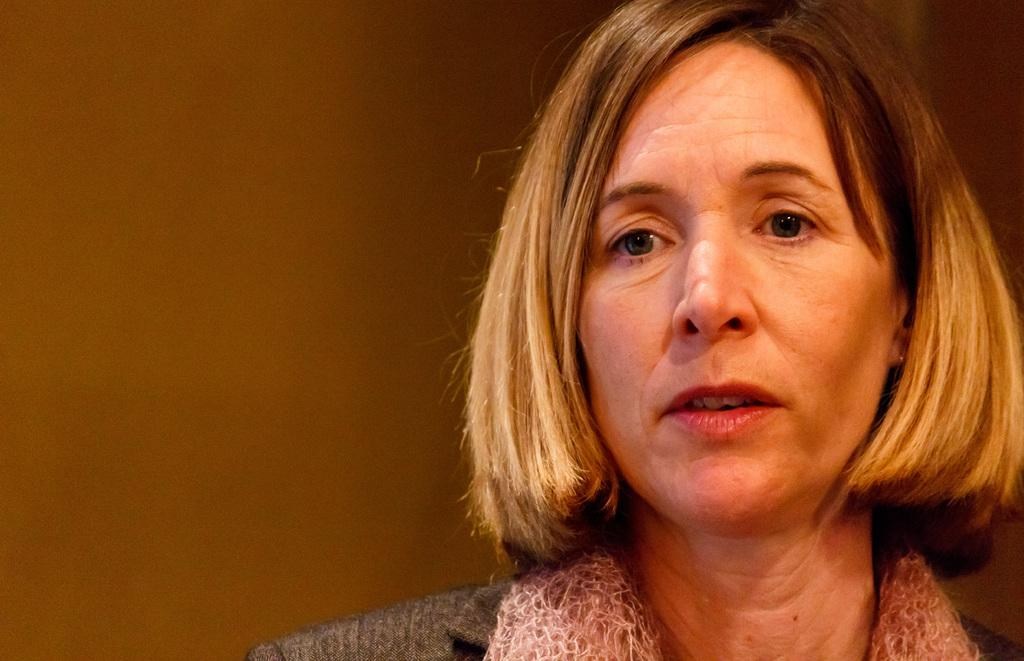Who is present in the image? There is a lady in the image. What invention is the lady holding in her hand in the image? There is no invention visible in the image; the lady is the only subject present. 